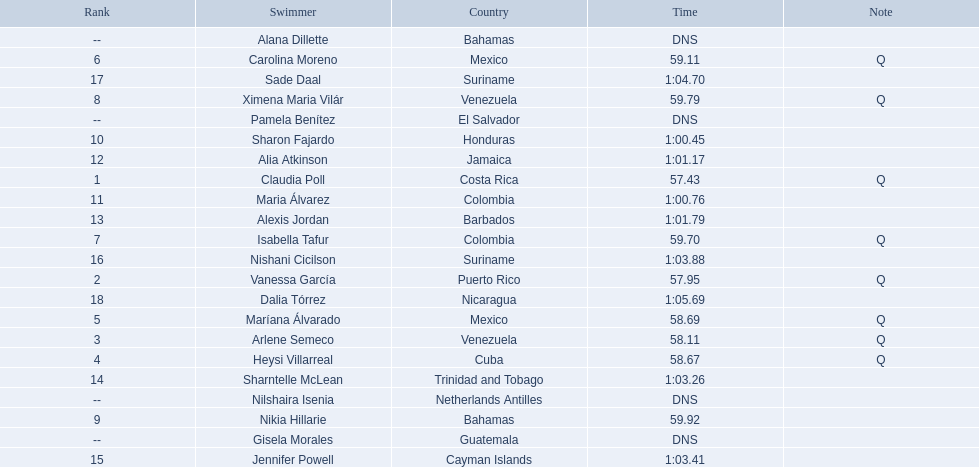Who were all of the swimmers in the women's 100 metre freestyle? Claudia Poll, Vanessa García, Arlene Semeco, Heysi Villarreal, Maríana Álvarado, Carolina Moreno, Isabella Tafur, Ximena Maria Vilár, Nikia Hillarie, Sharon Fajardo, Maria Álvarez, Alia Atkinson, Alexis Jordan, Sharntelle McLean, Jennifer Powell, Nishani Cicilson, Sade Daal, Dalia Tórrez, Gisela Morales, Alana Dillette, Pamela Benítez, Nilshaira Isenia. Where was each swimmer from? Costa Rica, Puerto Rico, Venezuela, Cuba, Mexico, Mexico, Colombia, Venezuela, Bahamas, Honduras, Colombia, Jamaica, Barbados, Trinidad and Tobago, Cayman Islands, Suriname, Suriname, Nicaragua, Guatemala, Bahamas, El Salvador, Netherlands Antilles. What were their ranks? 1, 2, 3, 4, 5, 6, 7, 8, 9, 10, 11, 12, 13, 14, 15, 16, 17, 18, --, --, --, --. Who was in the top eight? Claudia Poll, Vanessa García, Arlene Semeco, Heysi Villarreal, Maríana Álvarado, Carolina Moreno, Isabella Tafur, Ximena Maria Vilár. Of those swimmers, which one was from cuba? Heysi Villarreal. 